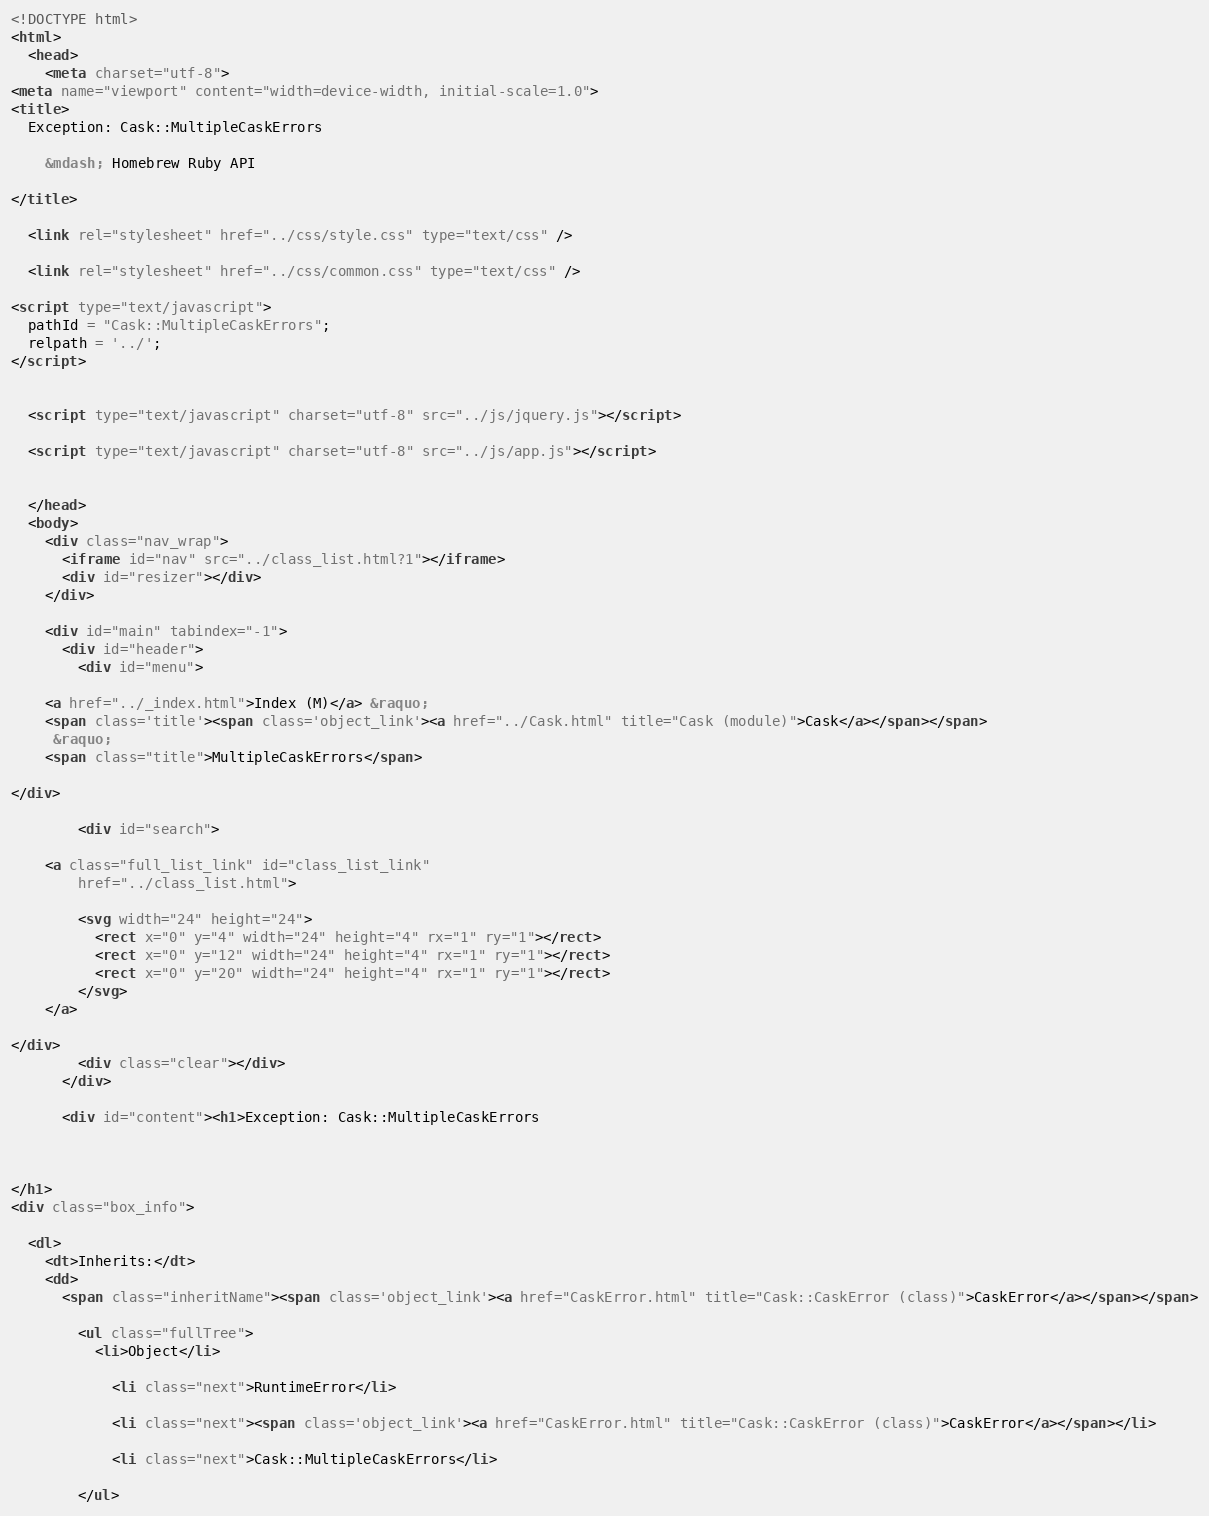<code> <loc_0><loc_0><loc_500><loc_500><_HTML_><!DOCTYPE html>
<html>
  <head>
    <meta charset="utf-8">
<meta name="viewport" content="width=device-width, initial-scale=1.0">
<title>
  Exception: Cask::MultipleCaskErrors
  
    &mdash; Homebrew Ruby API
  
</title>

  <link rel="stylesheet" href="../css/style.css" type="text/css" />

  <link rel="stylesheet" href="../css/common.css" type="text/css" />

<script type="text/javascript">
  pathId = "Cask::MultipleCaskErrors";
  relpath = '../';
</script>


  <script type="text/javascript" charset="utf-8" src="../js/jquery.js"></script>

  <script type="text/javascript" charset="utf-8" src="../js/app.js"></script>


  </head>
  <body>
    <div class="nav_wrap">
      <iframe id="nav" src="../class_list.html?1"></iframe>
      <div id="resizer"></div>
    </div>

    <div id="main" tabindex="-1">
      <div id="header">
        <div id="menu">
  
    <a href="../_index.html">Index (M)</a> &raquo;
    <span class='title'><span class='object_link'><a href="../Cask.html" title="Cask (module)">Cask</a></span></span>
     &raquo; 
    <span class="title">MultipleCaskErrors</span>
  
</div>

        <div id="search">
  
    <a class="full_list_link" id="class_list_link"
        href="../class_list.html">

        <svg width="24" height="24">
          <rect x="0" y="4" width="24" height="4" rx="1" ry="1"></rect>
          <rect x="0" y="12" width="24" height="4" rx="1" ry="1"></rect>
          <rect x="0" y="20" width="24" height="4" rx="1" ry="1"></rect>
        </svg>
    </a>
  
</div>
        <div class="clear"></div>
      </div>

      <div id="content"><h1>Exception: Cask::MultipleCaskErrors
  
  
  
</h1>
<div class="box_info">
  
  <dl>
    <dt>Inherits:</dt>
    <dd>
      <span class="inheritName"><span class='object_link'><a href="CaskError.html" title="Cask::CaskError (class)">CaskError</a></span></span>
      
        <ul class="fullTree">
          <li>Object</li>
          
            <li class="next">RuntimeError</li>
          
            <li class="next"><span class='object_link'><a href="CaskError.html" title="Cask::CaskError (class)">CaskError</a></span></li>
          
            <li class="next">Cask::MultipleCaskErrors</li>
          
        </ul></code> 